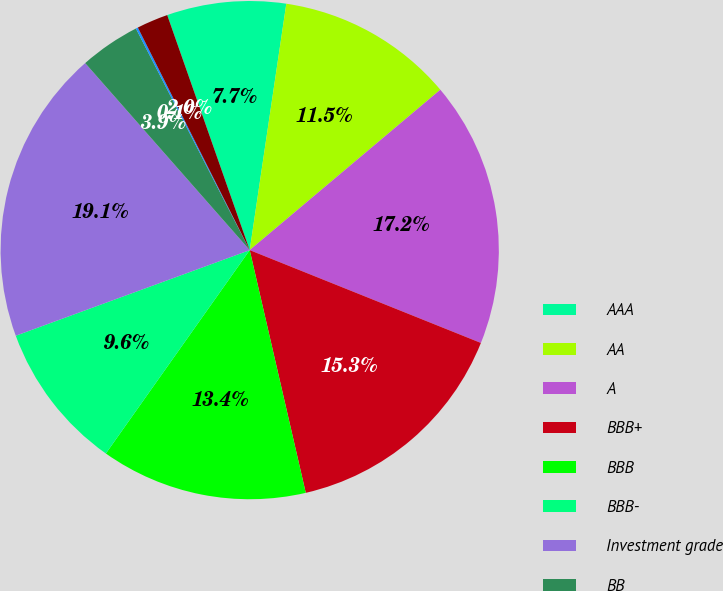<chart> <loc_0><loc_0><loc_500><loc_500><pie_chart><fcel>AAA<fcel>AA<fcel>A<fcel>BBB+<fcel>BBB<fcel>BBB-<fcel>Investment grade<fcel>BB<fcel>B<fcel>Below B<nl><fcel>7.72%<fcel>11.52%<fcel>17.21%<fcel>15.31%<fcel>13.41%<fcel>9.62%<fcel>19.1%<fcel>3.93%<fcel>0.14%<fcel>2.04%<nl></chart> 